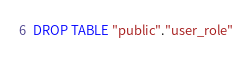Convert code to text. <code><loc_0><loc_0><loc_500><loc_500><_SQL_>DROP TABLE "public"."user_role"</code> 